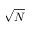Convert formula to latex. <formula><loc_0><loc_0><loc_500><loc_500>\sqrt { N }</formula> 